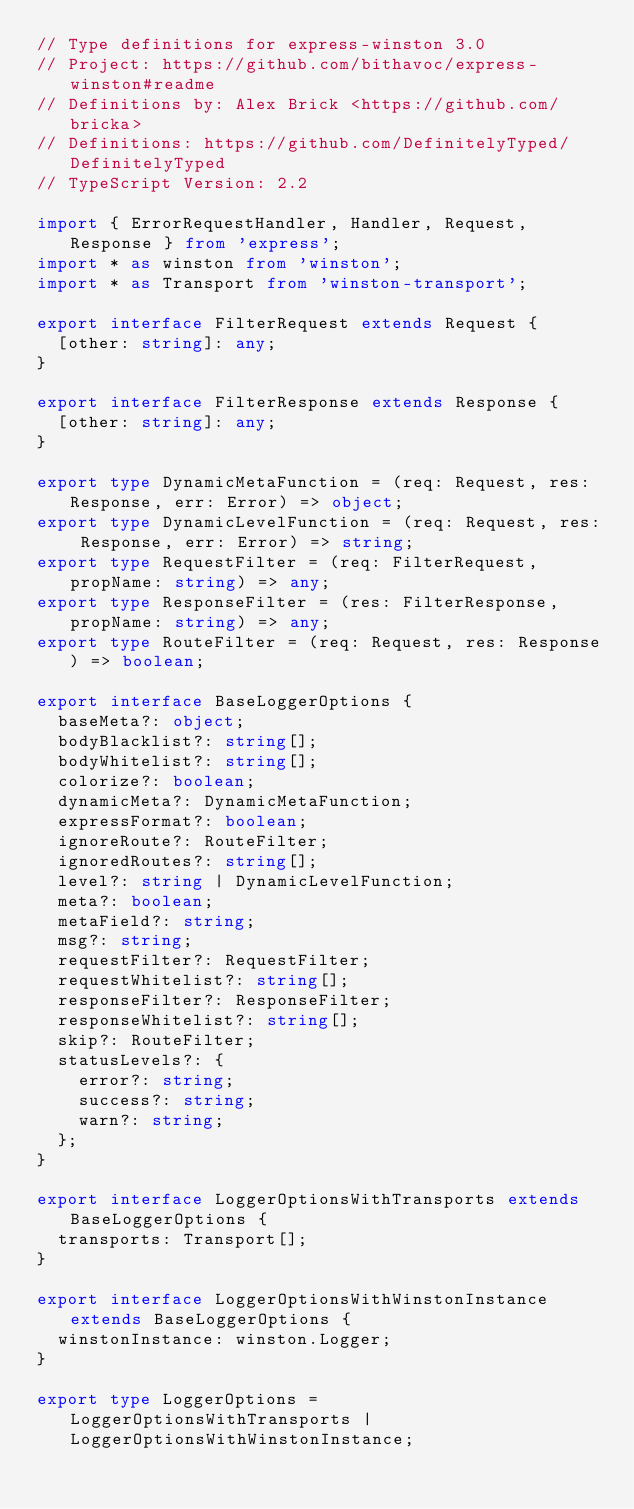Convert code to text. <code><loc_0><loc_0><loc_500><loc_500><_TypeScript_>// Type definitions for express-winston 3.0
// Project: https://github.com/bithavoc/express-winston#readme
// Definitions by: Alex Brick <https://github.com/bricka>
// Definitions: https://github.com/DefinitelyTyped/DefinitelyTyped
// TypeScript Version: 2.2

import { ErrorRequestHandler, Handler, Request, Response } from 'express';
import * as winston from 'winston';
import * as Transport from 'winston-transport';

export interface FilterRequest extends Request {
  [other: string]: any;
}

export interface FilterResponse extends Response {
  [other: string]: any;
}

export type DynamicMetaFunction = (req: Request, res: Response, err: Error) => object;
export type DynamicLevelFunction = (req: Request, res: Response, err: Error) => string;
export type RequestFilter = (req: FilterRequest, propName: string) => any;
export type ResponseFilter = (res: FilterResponse, propName: string) => any;
export type RouteFilter = (req: Request, res: Response) => boolean;

export interface BaseLoggerOptions {
  baseMeta?: object;
  bodyBlacklist?: string[];
  bodyWhitelist?: string[];
  colorize?: boolean;
  dynamicMeta?: DynamicMetaFunction;
  expressFormat?: boolean;
  ignoreRoute?: RouteFilter;
  ignoredRoutes?: string[];
  level?: string | DynamicLevelFunction;
  meta?: boolean;
  metaField?: string;
  msg?: string;
  requestFilter?: RequestFilter;
  requestWhitelist?: string[];
  responseFilter?: ResponseFilter;
  responseWhitelist?: string[];
  skip?: RouteFilter;
  statusLevels?: {
    error?: string;
    success?: string;
    warn?: string;
  };
}

export interface LoggerOptionsWithTransports extends BaseLoggerOptions {
  transports: Transport[];
}

export interface LoggerOptionsWithWinstonInstance extends BaseLoggerOptions {
  winstonInstance: winston.Logger;
}

export type LoggerOptions = LoggerOptionsWithTransports | LoggerOptionsWithWinstonInstance;
</code> 